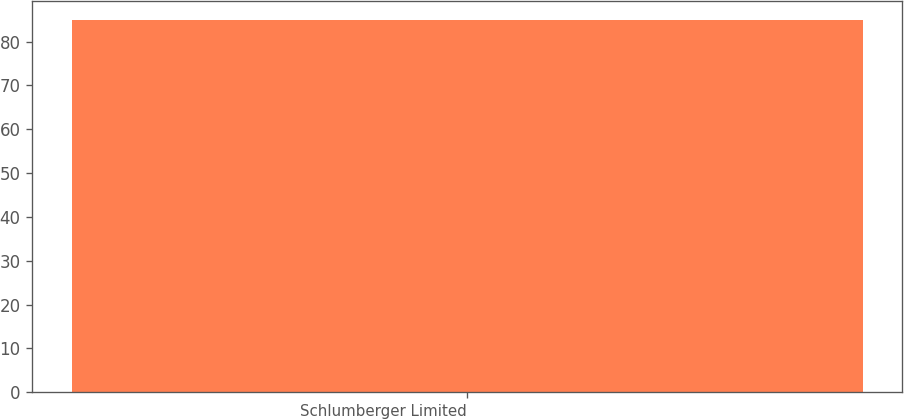<chart> <loc_0><loc_0><loc_500><loc_500><bar_chart><fcel>Schlumberger Limited<nl><fcel>85<nl></chart> 